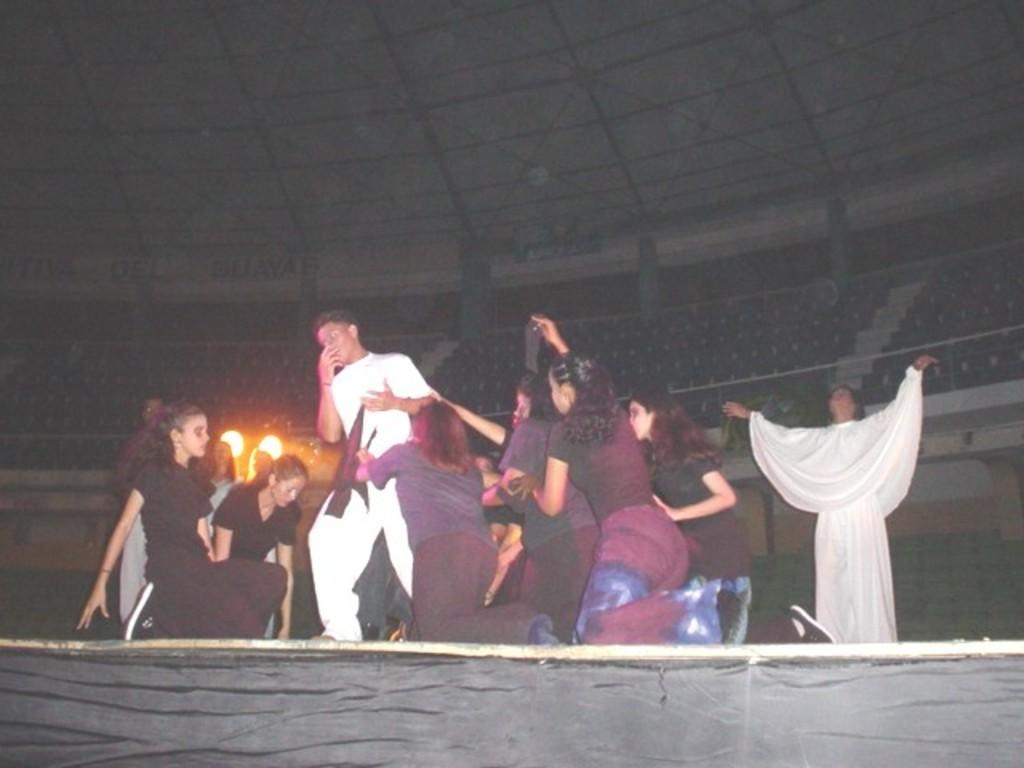What is happening on the dais in the image? There is a group performing on a dais in the image. What can be seen in the background of the image? There are seats, grills, and a shed in the background of the image. What type of camera is being used by the group to capture their performance in the image? There is no camera visible in the image, and it is not mentioned that the group is capturing their performance. 